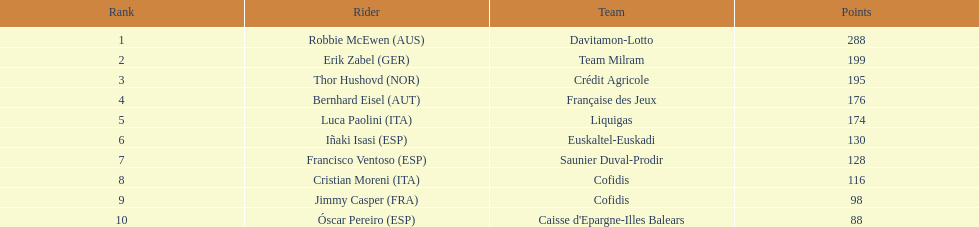How many more points did erik zabel score than franciso ventoso? 71. 